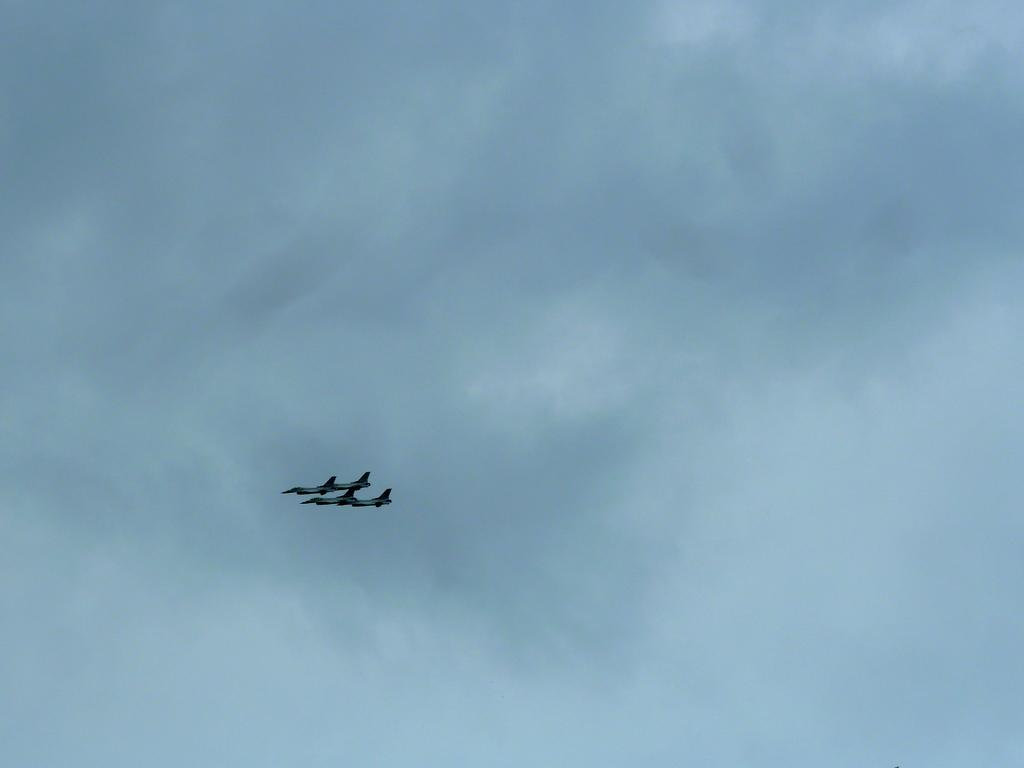What is the main subject of the image? The main subject of the image is two aircrafts. Where are the aircrafts located in the image? The aircrafts are in the air. What can be seen in the background of the image? There are clouds and the sky visible in the background of the image. What type of furniture can be seen in the image? There is no furniture present in the image; it features two aircrafts in the air. What is being served for lunch in the image? There is no lunch being served in the image; it focuses on the aircrafts and the sky. 